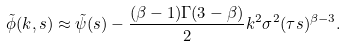<formula> <loc_0><loc_0><loc_500><loc_500>\tilde { \phi } ( k , s ) \approx \tilde { \psi } ( s ) - \frac { ( \beta - 1 ) \Gamma ( 3 - \beta ) } { 2 } k ^ { 2 } \sigma ^ { 2 } ( \tau s ) ^ { \beta - 3 } .</formula> 